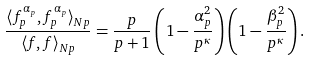Convert formula to latex. <formula><loc_0><loc_0><loc_500><loc_500>\frac { \langle f _ { p } ^ { \alpha _ { p } } , f _ { p } ^ { \alpha _ { p } } \rangle _ { N p } } { \langle f , f \rangle _ { N p } } = \frac { p } { p + 1 } \left ( 1 - \frac { \alpha _ { p } ^ { 2 } } { p ^ { \kappa } } \right ) \left ( 1 - \frac { \beta _ { p } ^ { 2 } } { p ^ { \kappa } } \right ) .</formula> 